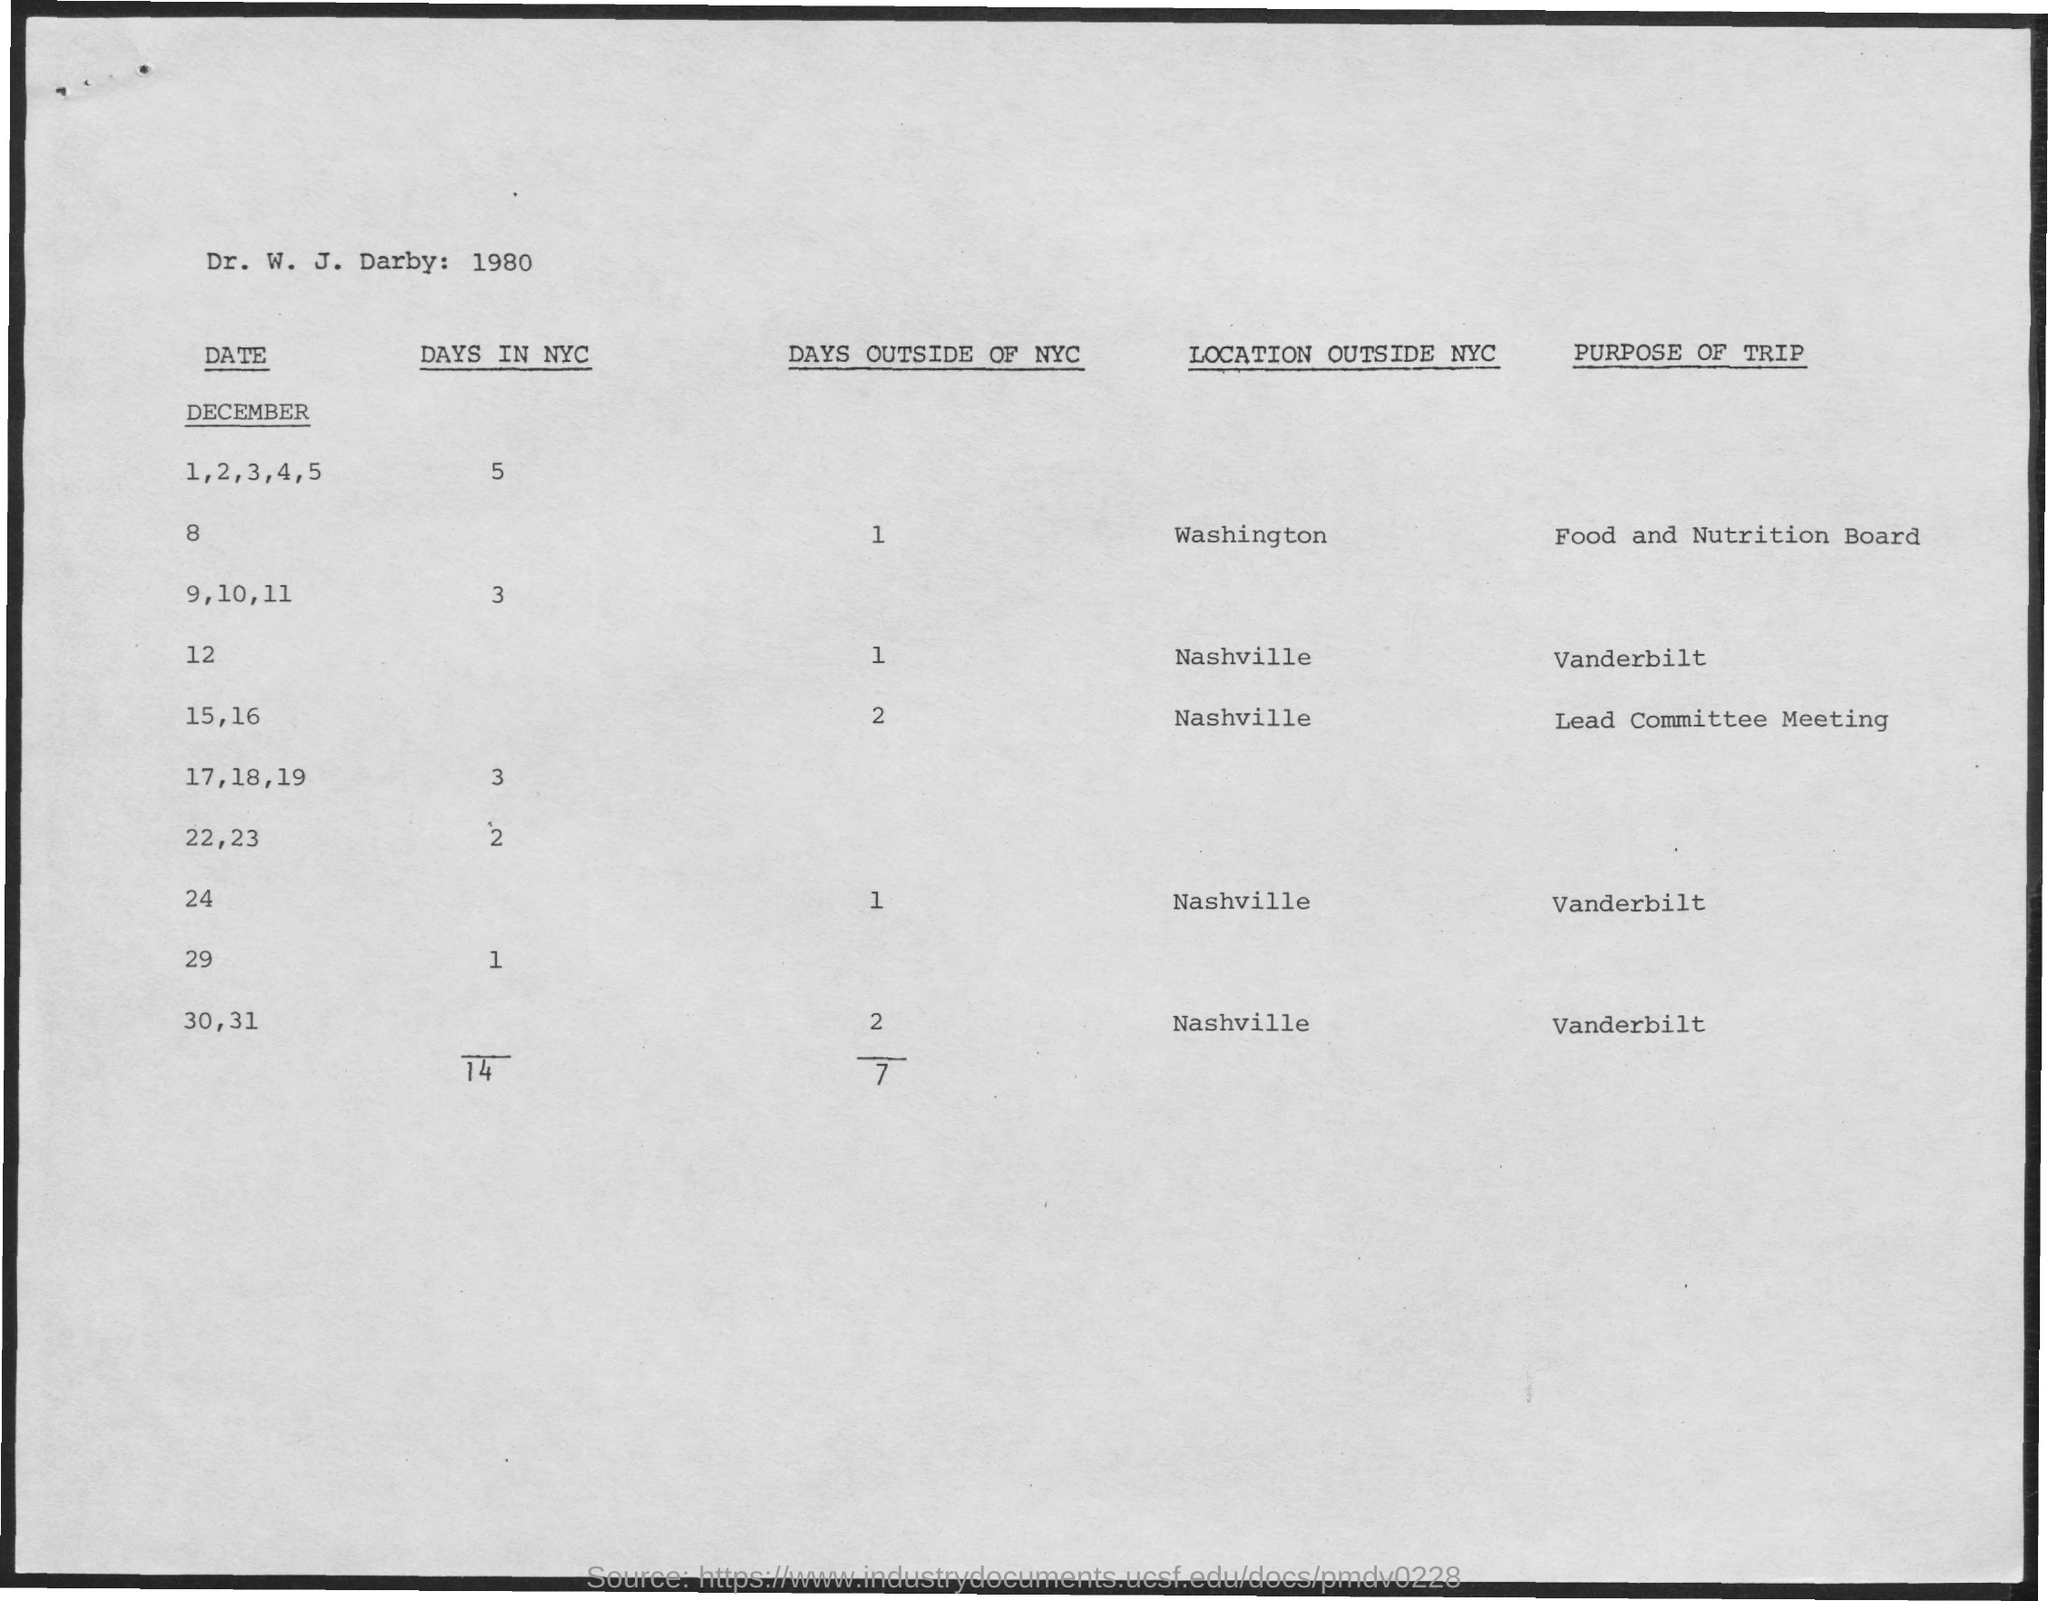Give some essential details in this illustration. On which day in December is the trip to the Food and Nutrition Board? It will be on the 8th. On December 15 and 16, I will be attending a Lead Committee Meeting on a trip. 